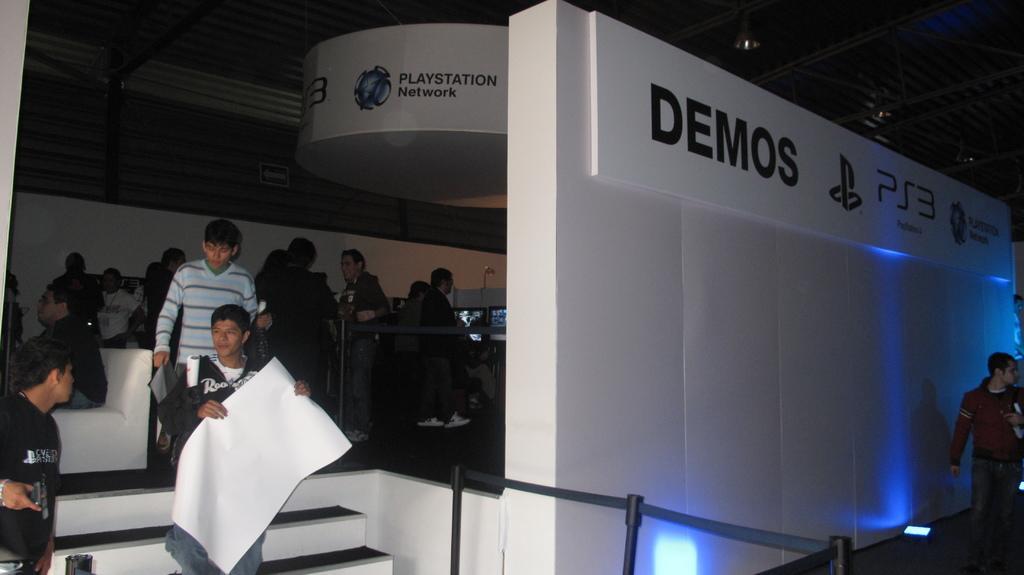Describe this image in one or two sentences. In this image there is a person holding a chart in his hand is walking on the stairs, behind him there are few other people, in the background of the image there is a playstation network demos. 